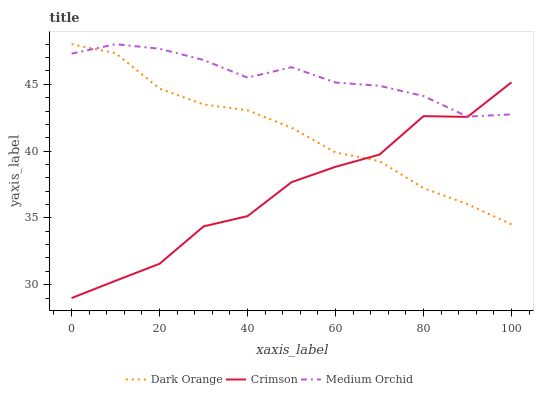Does Dark Orange have the minimum area under the curve?
Answer yes or no. No. Does Dark Orange have the maximum area under the curve?
Answer yes or no. No. Is Medium Orchid the smoothest?
Answer yes or no. No. Is Medium Orchid the roughest?
Answer yes or no. No. Does Dark Orange have the lowest value?
Answer yes or no. No. 